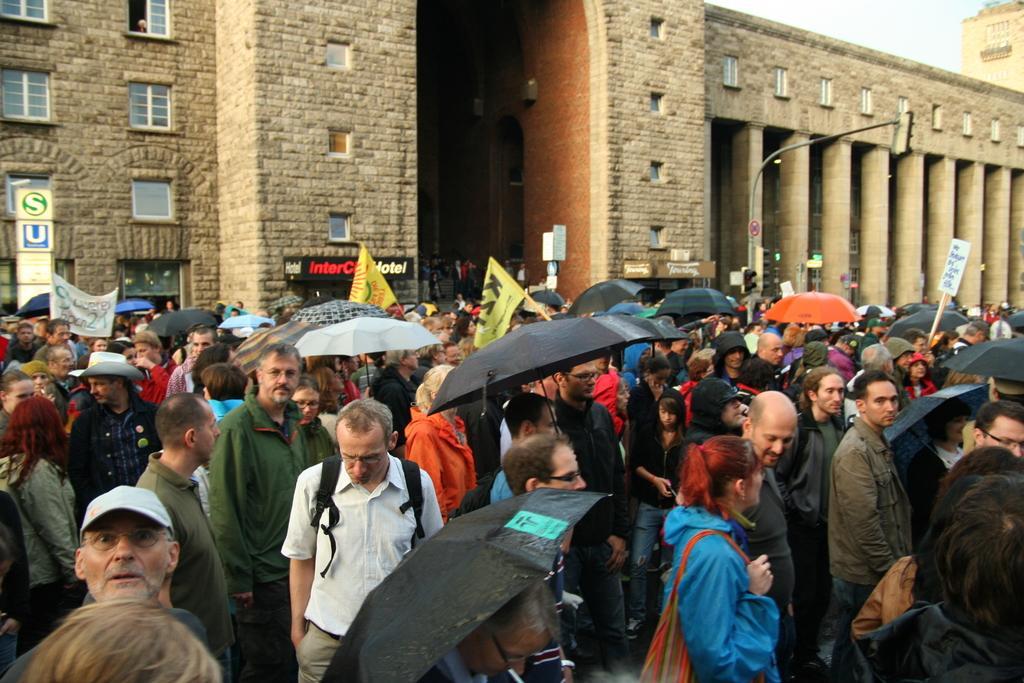In one or two sentences, can you explain what this image depicts? In this picture I can see group of people standing and holding umbrellas, placards and flags. I can see a building, boards, pillars, and in the background there is the sky. 